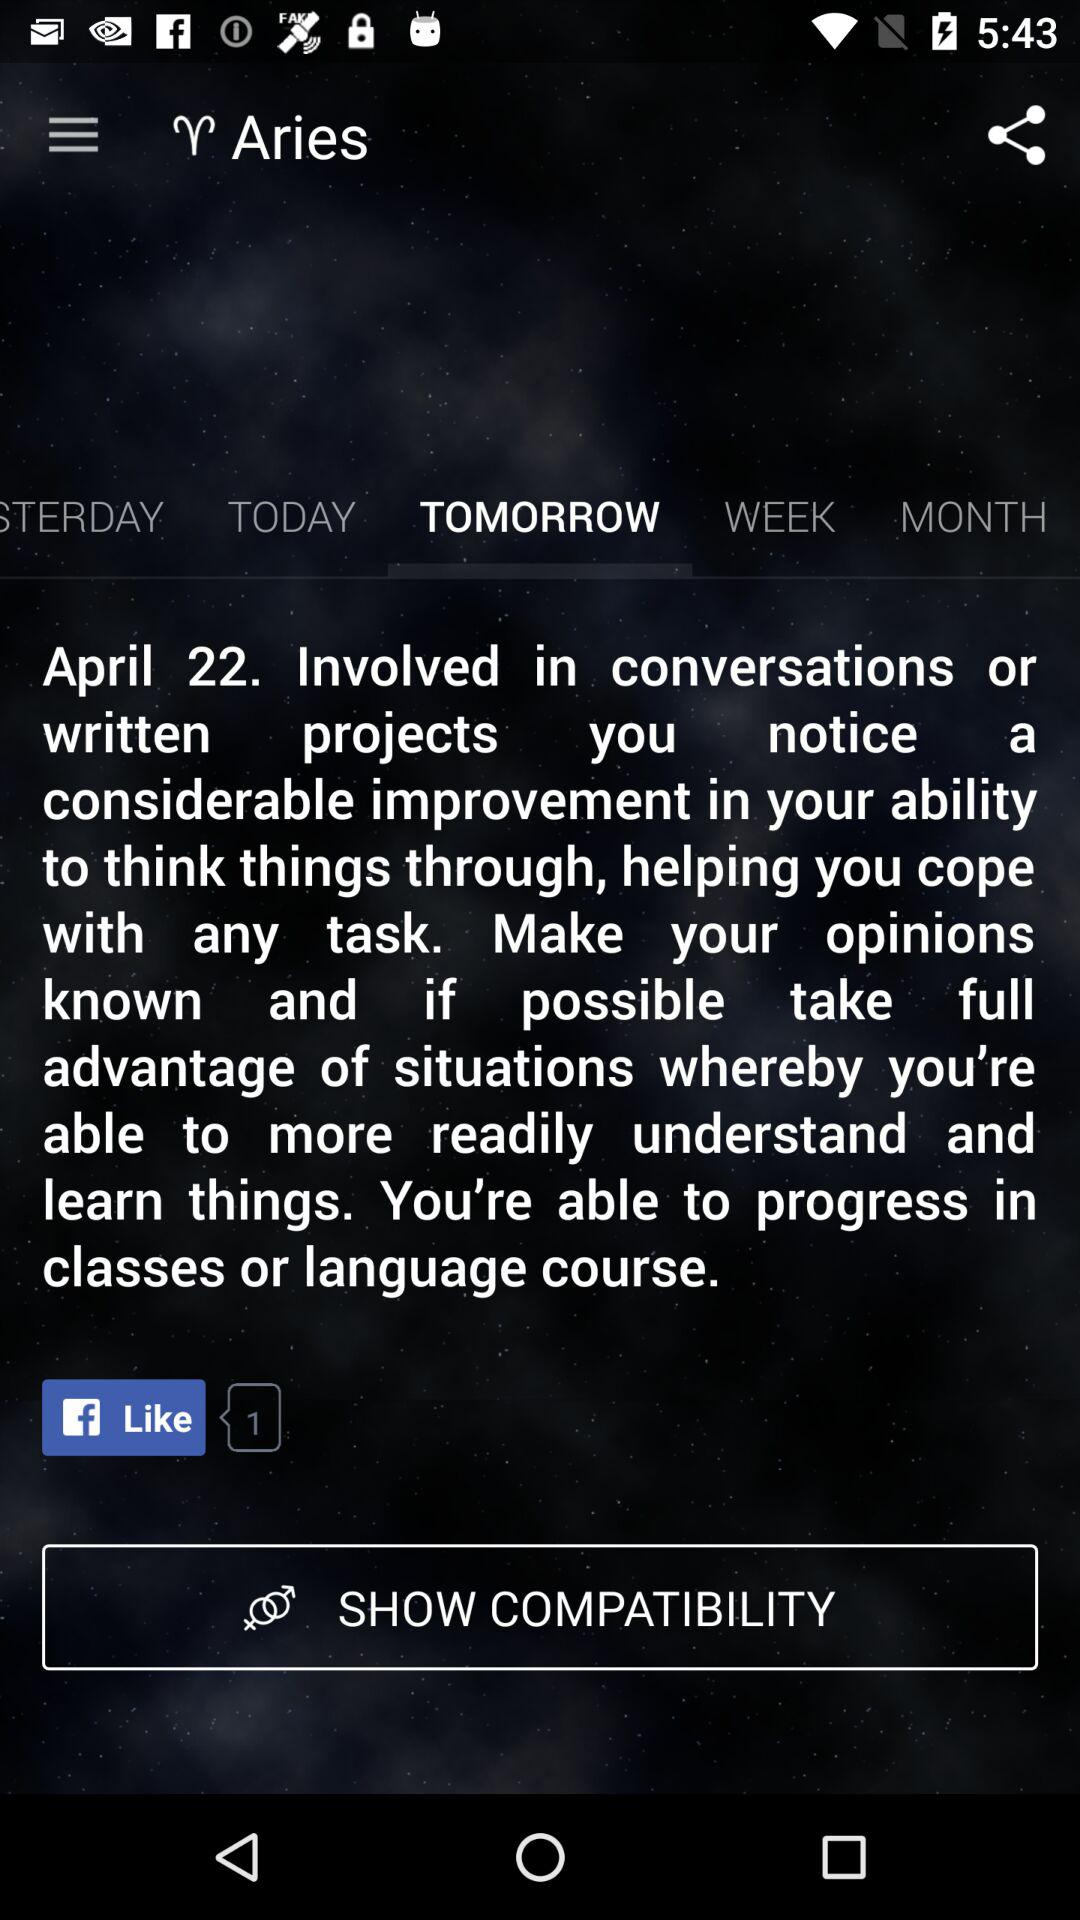How many days are there between today and the day after tomorrow?
Answer the question using a single word or phrase. 2 